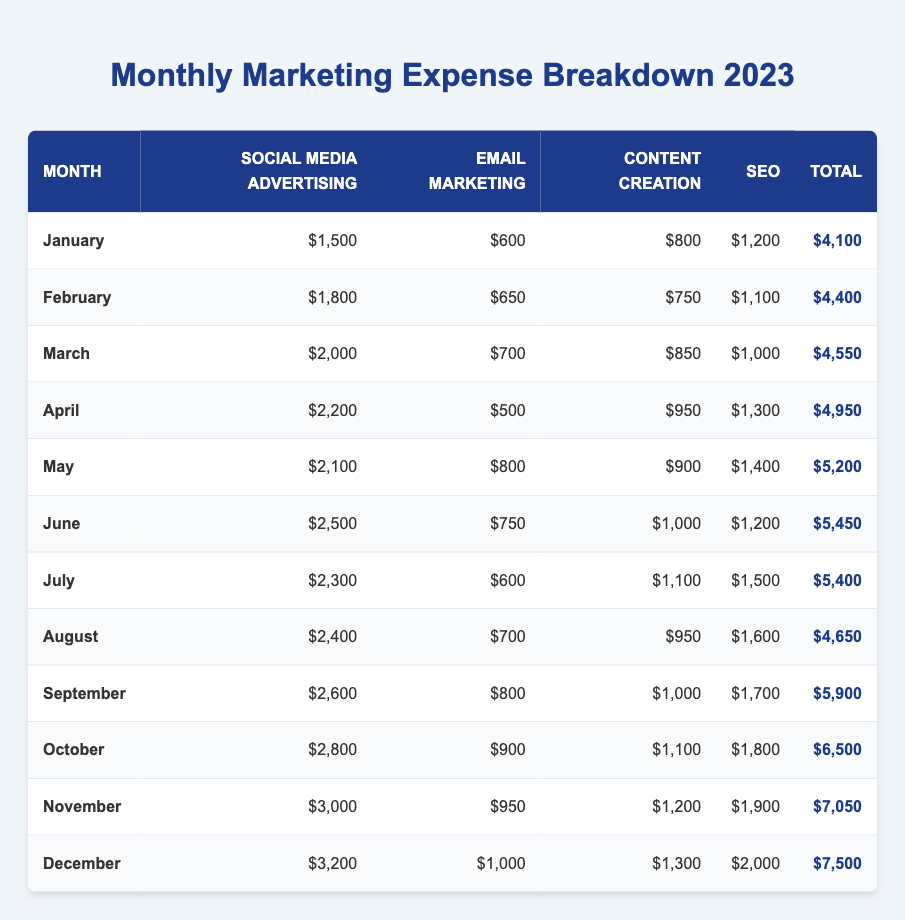What's the total marketing expense for April? The total expense for April is directly listed in the table under the "Total" column, which shows $4,950 for that month.
Answer: $4,950 Which month had the highest Social Media Advertising expense? By comparing the values in the "Social Media Advertising" column, December shows the highest value of $3,200.
Answer: December What is the average total expense over the year? To find the average, sum all the monthly totals: (4100 + 4400 + 4550 + 4950 + 5200 + 5450 + 5400 + 4650 + 5900 + 6500 + 7050 + 7500) = 61,100. Then divide by 12: 61,100 / 12 = 5,091.67.
Answer: $5,091.67 Did any month have more than $6,000 in total expenses? By looking at the "Total" column, November ($7,050) and December ($7,500) both exceed $6,000. Thus, the answer is yes.
Answer: Yes What is the difference in expenses between January and December? To find this difference, subtract January's total ($4,100) from December's total ($7,500): $7,500 - $4,100 = $3,400.
Answer: $3,400 Which month saw the lowest Email Marketing expense, and what was that amount? The lowest Email Marketing expense is in April with $500, which can be checked in the "Email Marketing" column.
Answer: $500 in April What was the total marketing expense for the first half of the year (January to June)? To compute this, sum the totals from January to June: $4,100 + $4,400 + $4,550 + $4,950 + $5,200 + $5,450 = $28,650.
Answer: $28,650 Which marketing channel had the highest expense in October, and how much was spent? In October, the largest expense is for Social Media Advertising with $2,800, which can be checked in the relevant column for that month.
Answer: $2,800 for Social Media Advertising How does August's total expense compare to July's total? August's total is $4,650 and July's total is $5,400. To compare, subtract August from July: $5,400 - $4,650 = $750, so July is higher by $750.
Answer: July is $750 higher than August What percentage of the total budget for the year was allocated to March? First, March's total expense is $4,550. The total for the year is $61,100. To find the percentage: ($4,550 / $61,100) * 100 = approximately 7.43%.
Answer: 7.43% 